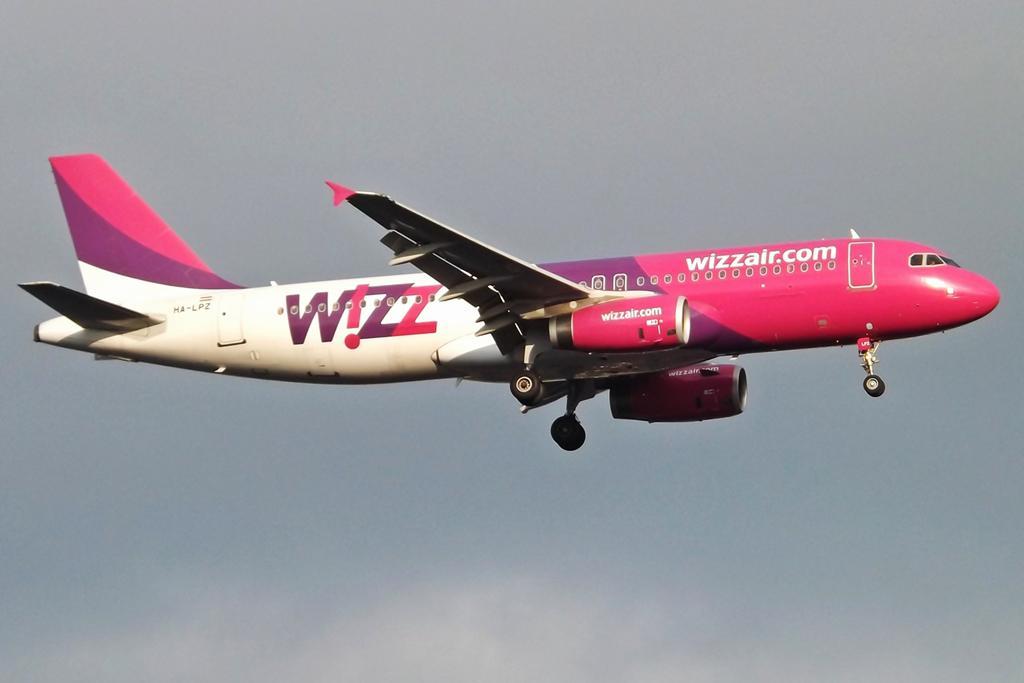What website is represented on the jet?
Provide a short and direct response. Wizzair.com. What is this airline?
Make the answer very short. Wizz. 